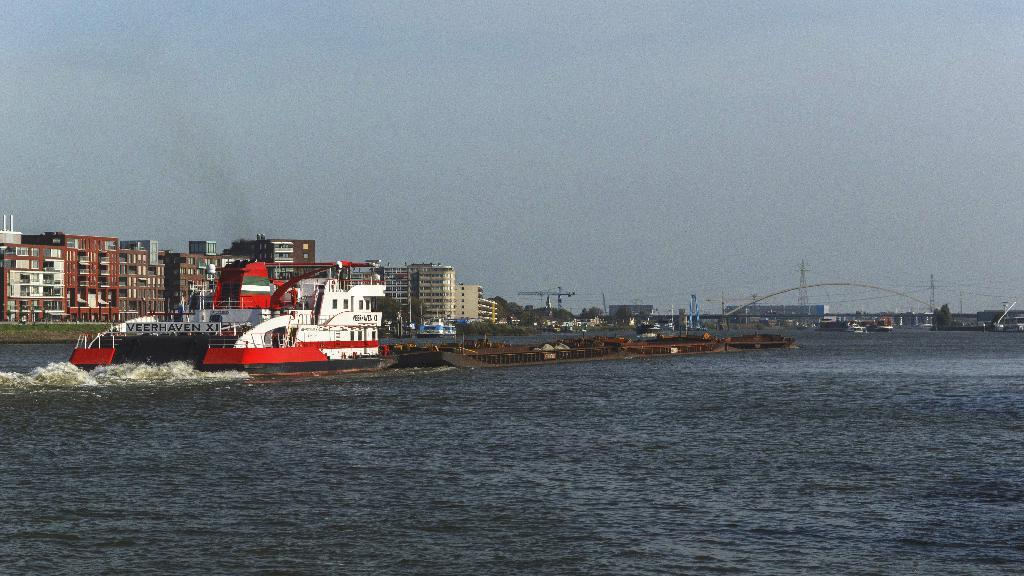What is in the water in the image? There are ships in the water in the image. What can be observed about the water's movement? Waves are visible in the water. What is visible in the background of the image? There are buildings, wires, and towers in the background. What emotion is the mind feeling towards the plane in the image? There is no mind or plane present in the image, so it is not possible to determine any emotions towards a plane. 